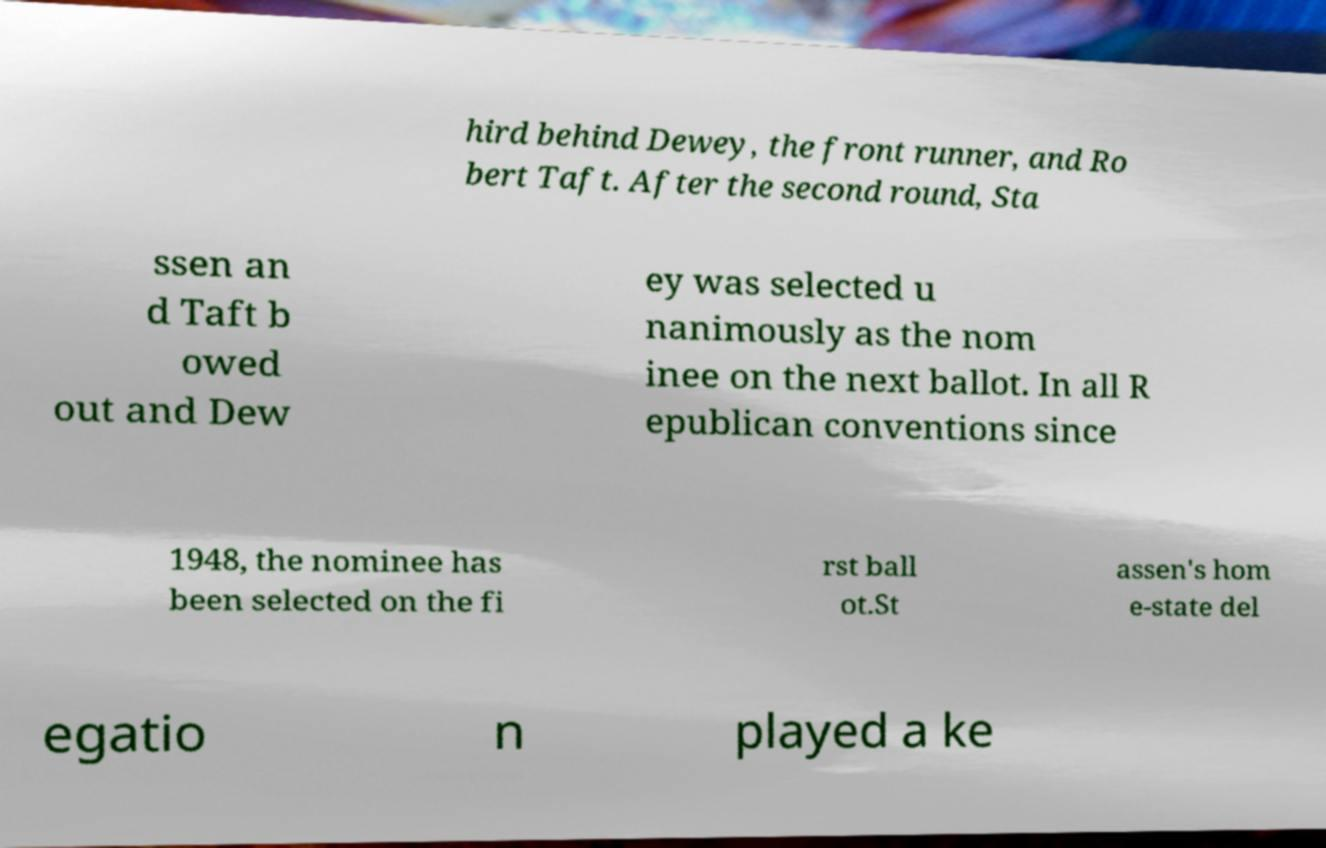Please read and relay the text visible in this image. What does it say? hird behind Dewey, the front runner, and Ro bert Taft. After the second round, Sta ssen an d Taft b owed out and Dew ey was selected u nanimously as the nom inee on the next ballot. In all R epublican conventions since 1948, the nominee has been selected on the fi rst ball ot.St assen's hom e-state del egatio n played a ke 